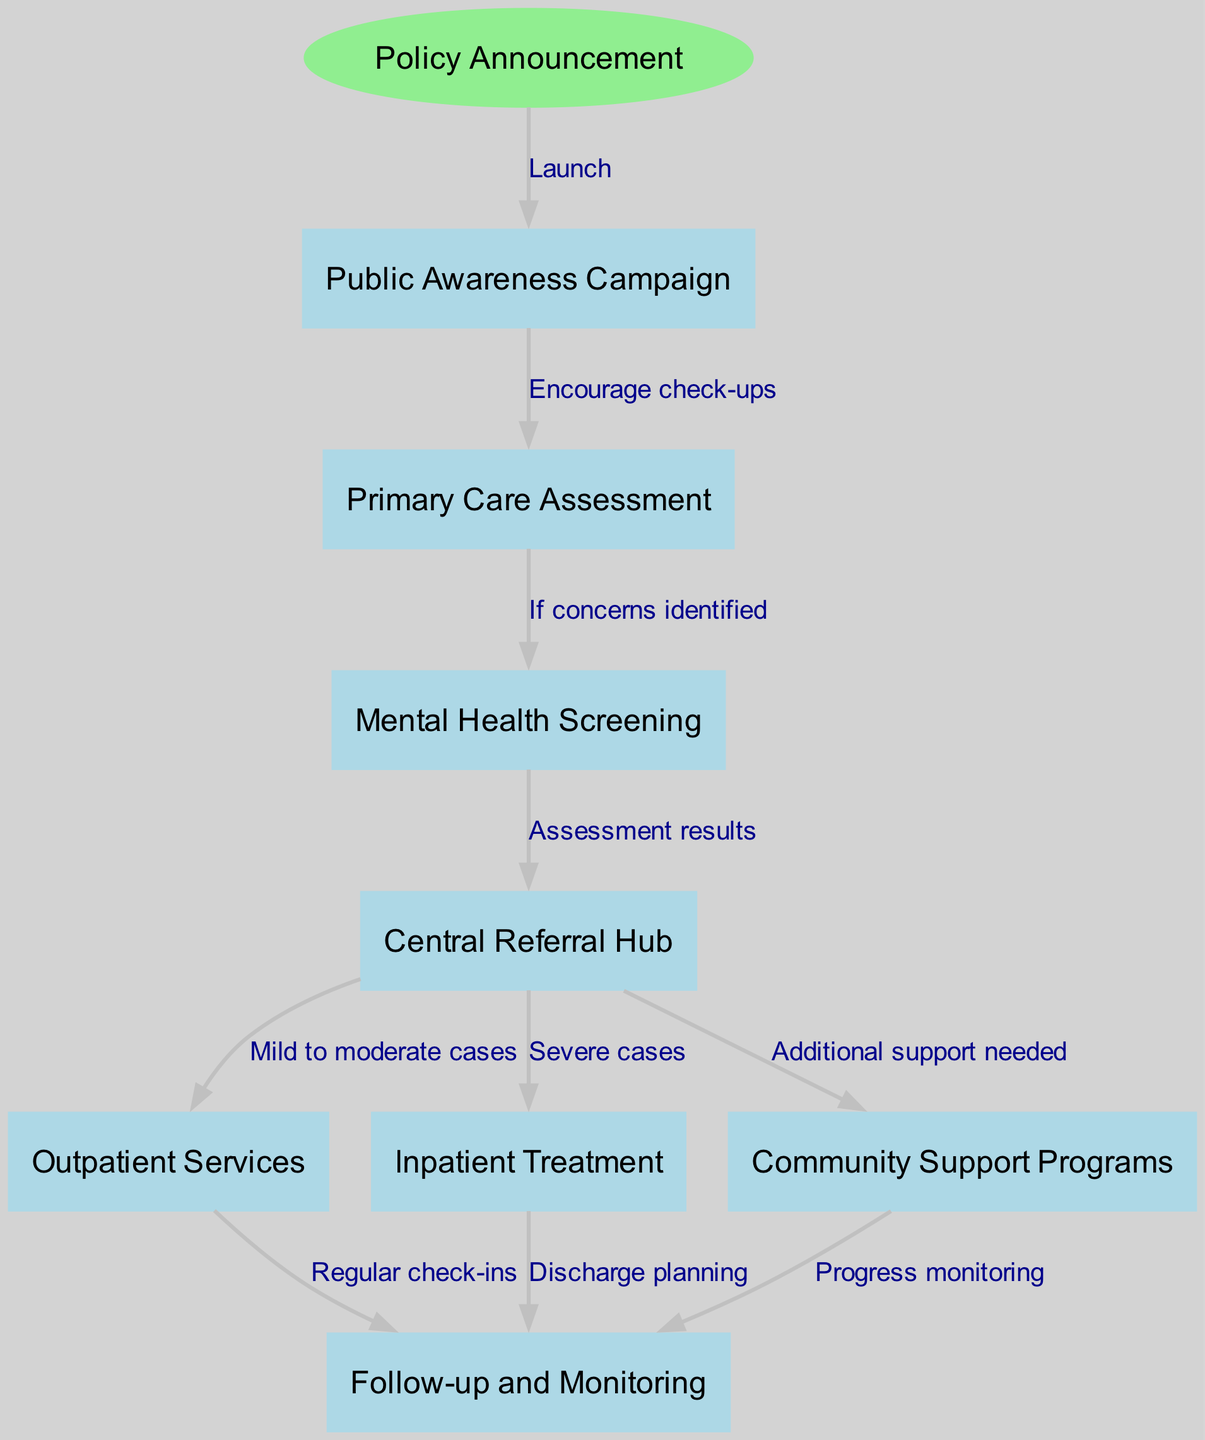What is the first step in the clinical pathway? The first step identified in the diagram is labeled "Policy Announcement." This is shown as the starting point of the pathway with an explicit designation.
Answer: Policy Announcement How many types of treatment options are shown in the diagram? In the diagram, there are three treatment options indicated, which are "Outpatient Services," "Inpatient Treatment," and "Community Support Programs." Each of these is represented as a distinct node connected to the "Central Referral Hub."
Answer: Three What node comes after the "Mental Health Screening"? Following the "Mental Health Screening," the next node is the "Central Referral Hub," as indicated by the directed edge from screening to the hub. This flow shows that the results from the screening lead to the referral hub for further action.
Answer: Central Referral Hub What type of cases are directed to inpatient treatment? The diagram indicates that "Severe cases" are directed to "Inpatient Treatment," as evidenced by the edge connecting the "Central Referral Hub" to the "Inpatient Treatment" node with the corresponding label.
Answer: Severe cases Which process is associated with regular check-ins? The process associated with regular check-ins is "Outpatient Services." The diagram shows an edge from "Outpatient Services" to "Follow-up and Monitoring," indicating that check-ins occur at this stage of treatment.
Answer: Follow-up and Monitoring What happens if additional support is needed? If additional support is needed, the pathway directs to "Community Support Programs." This is indicated by the edge from the "Central Referral Hub" identifying a need for additional assistance, leading to community support resources.
Answer: Community Support Programs What does follow-up involve after inpatient treatment? Follow-up after inpatient treatment involves "Discharge planning," as noted by the directed edge from "Inpatient Treatment" to "Follow-up and Monitoring." This indicates that discharge planning is a key component of follow-up care in inpatient settings.
Answer: Discharge planning Which step encourages the public to seek check-ups? The step that encourages the public to seek check-ups is the "Public Awareness Campaign." This node is linked to "Primary Care Assessment" with an edge labeled "Encourage check-ups," showing its role in promoting health services.
Answer: Public Awareness Campaign 